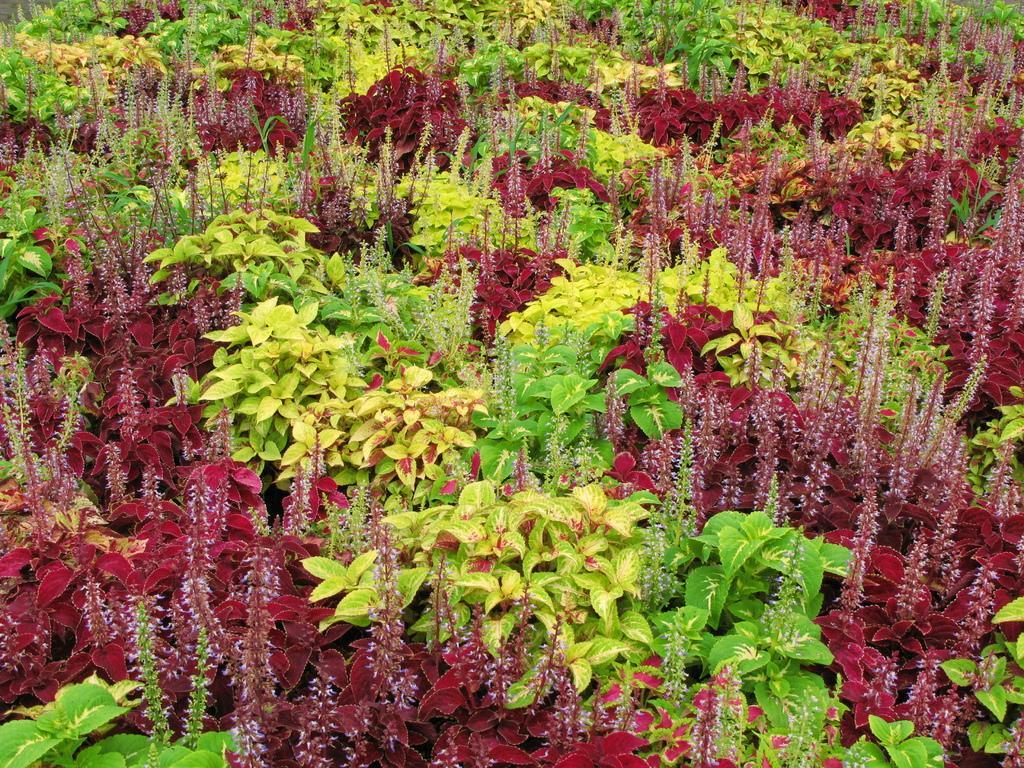Can you describe this image briefly? In this picture I can see there are few plants and there are green, yellow and maroon leaves. 